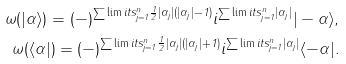<formula> <loc_0><loc_0><loc_500><loc_500>\omega ( | \alpha \rangle ) = ( - ) ^ { \sum \lim i t s _ { j = 1 } ^ { n } \frac { 1 } { 2 } | \alpha _ { j } | ( | \alpha _ { j } | - 1 ) } i ^ { \sum \lim i t s _ { j = 1 } ^ { n } | \alpha _ { j } | } | - \alpha \rangle , \\ \omega ( \langle \alpha | ) = ( - ) ^ { \sum \lim i t s _ { j = 1 } ^ { n } \frac { 1 } { 2 } | \alpha _ { j } | ( | \alpha _ { j } | + 1 ) } i ^ { \sum \lim i t s _ { j = 1 } ^ { n } | \alpha _ { j } | } \langle - \alpha | .</formula> 